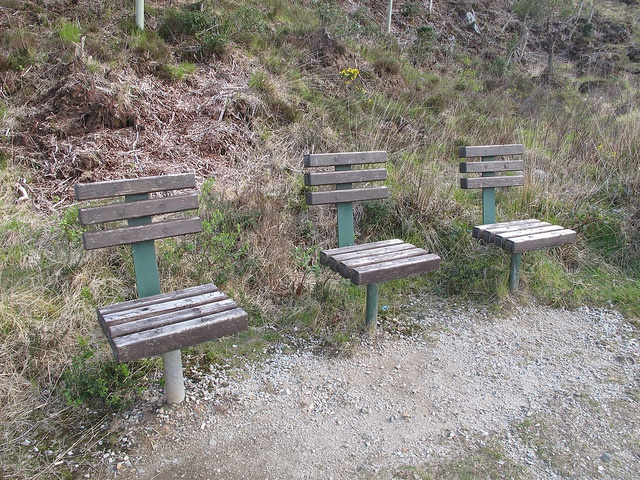Describe the objects in this image and their specific colors. I can see bench in gray, darkgray, and lavender tones, bench in gray, darkgray, lightgray, and teal tones, and bench in gray, darkgray, white, and teal tones in this image. 